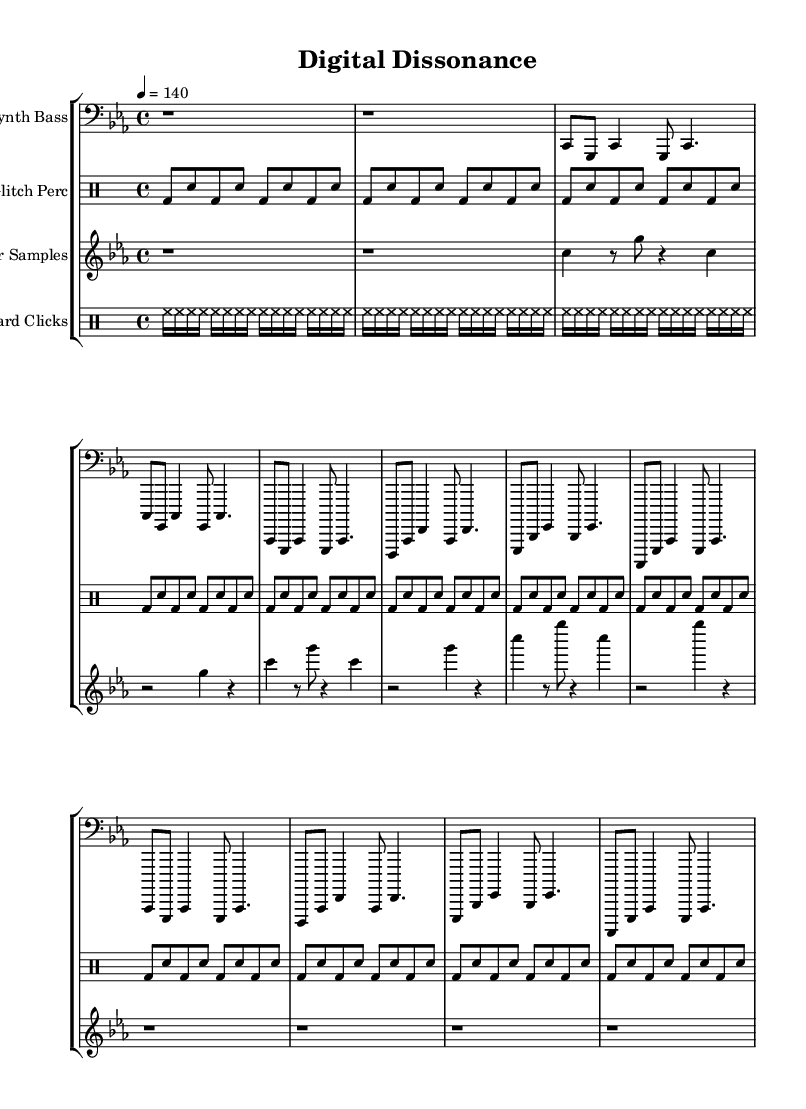What is the key signature of this music? The key signature is C minor, indicated by the presence of three flats (B flat, E flat, A flat) in the key signature section.
Answer: C minor What is the time signature of this music? The time signature is 4/4, shown at the beginning of the score, which indicates that there are four beats in each measure.
Answer: 4/4 What is the tempo marking in this piece? The tempo marking is 140, specified at the beginning of the score with the annotation "4 = 140," indicating that there are 140 beats per minute.
Answer: 140 How many measures are present in the synth bass section? By counting the measures indicated in the synth bass part, there are a total of 8 measures outlined.
Answer: 8 Which instrument has the rhythm primarily consisting of bass drum and snare? The instrument that features the rhythm constructed from bass drum and snare hits is the glitch percussion, as seen in its respective section.
Answer: Glitch Perc What unique musical elements characterize the error samples in this piece? The error samples section is characterized by a series of rests and notes that create dissonance, embodying glitch elements, which can be noted through the presence of frequent rests (r) compared to actual notes.
Answer: Dissonance How many repetitions are used in the keyboard clicks section? The keyboard clicks section contains two distinct repetition patterns: one with 8 repetitions and another with 16 repetitions, making a total of 24 clicks as indicated under the drumming notation.
Answer: 24 